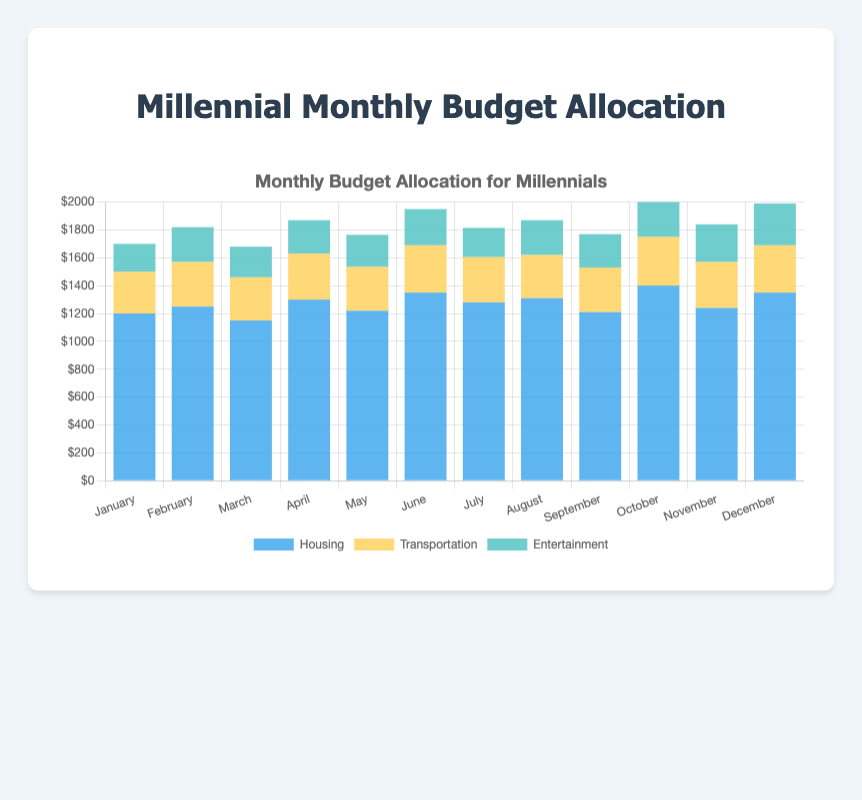What is the total amount spent on transportation in the first quarter of the year? Sum the transportation expenditures for January, February, and March: 300 (January) + 320 (February) + 310 (March) = 930
Answer: 930 Which month had the highest housing expenditure? By examining the height of the blue bars for each month, October has the highest housing expenditure at 1400
Answer: October Compare the total expenditure of May and June. Which month had the higher total? Sum and compare the expenditures for May (1220 + 315 + 230 = 1765) and June (1350 + 340 + 260 = 1950). June has the higher total
Answer: June What is the average entertainment expense for the entire year? Sum all monthly entertainment expenses and divide by 12: (200 + 250 + 220 + 240 + 230 + 260 + 210 + 250 + 240 + 280 + 270 + 300) / 12 = 2450 / 12 ≈ 204.17
Answer: 204.17 In which month was the transportation expense equal to the entertainment expense? By comparing the yellow and green bars for each month, August has both transportation and entertainment expenses at 250
Answer: August Which month had the lowest total expenditure? Sum the expenditures for each month and pick the one with the lowest total: January (1700), February (1820), March (1680), April (1870), May (1765), June (1950), July (1815), August (1870), September (1770), October (2030), November (1840), December (1990). March has the lowest total of 1680
Answer: March What is the difference in total expenditure between July and November? Calculate the totals for both months and find the difference: July (1280 + 325 + 210 = 1815) - November (1240 + 330 + 270 = 1840). The difference is 1840 - 1815 = 25
Answer: 25 How much more was spent on housing compared to entertainment in December? Subtract December's entertainment expense from its housing expense: 1350 (housing) - 300 (entertainment) = 1050
Answer: 1050 In how many months was the entertainment expense greater than $250? Examine the green bars and count the months where entertainment is more than 250: June (260), October (280), November (270), December (300). There are 4 such months
Answer: 4 What’s the total expenditure on entertainment in the second half of the year? Sum the entertainment expenses from July to December: 210 (July) + 250 (August) + 240 (September) + 280 (October) + 270 (November) + 300 (December) = 1550
Answer: 1550 